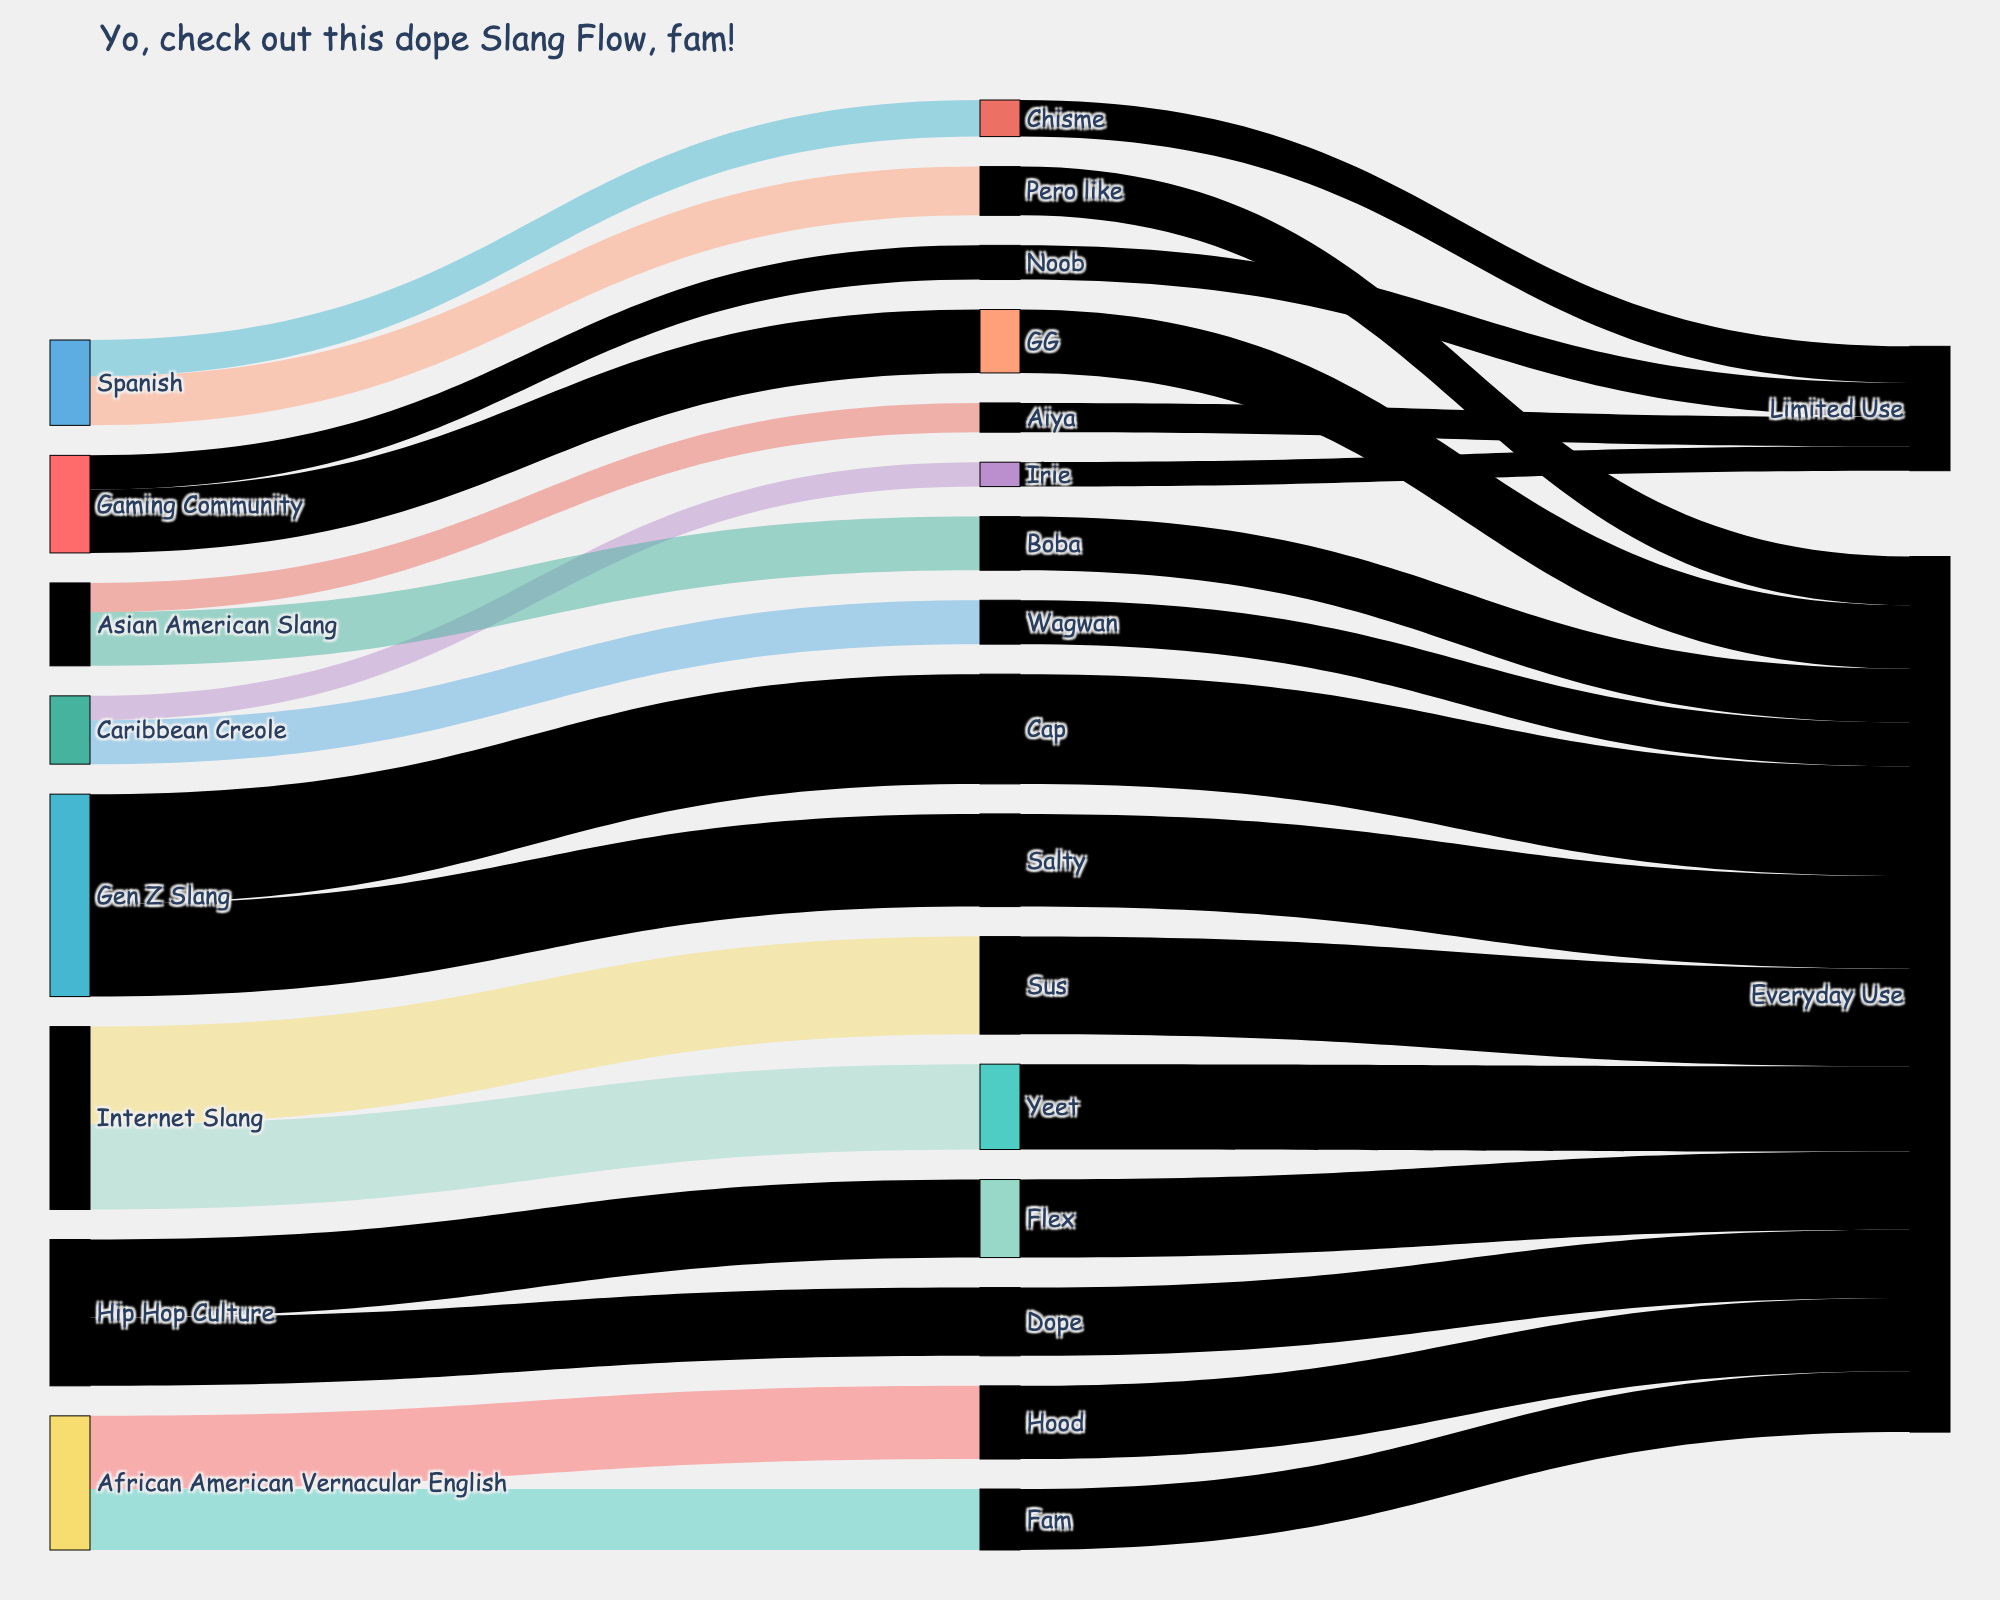Which slang term from Gen Z Slang has the highest adoption in everyday use? To find this, look at the "Gen Z Slang" category leading to "Everyday Use" and compare the values. "Cap" is 45, whereas "Salty" is 38. So, "Cap" has the highest adoption.
Answer: Cap What slang originating from Internet Slang has a higher value, "Yeet" or "Sus"? Check the values connected to "Internet Slang" in the "Everyday Use" category. "Yeet" has a value of 35 and "Sus" has a value of 40.
Answer: Sus What's the total value of slang terms that have a "Limited Use" adoption? Add the values seen in the "Limited Use" category: "Chisme" (15), "Aiya" (12), "Irie" (10), and "Noob" (14). The total is 15 + 12 + 10 + 14 = 51.
Answer: 51 Which source contributes the most slang words to "Everyday Use"? Compare the summed values leading to "Everyday Use" from each source. "Internet Slang" contributes (35+40=75), "African American Vernacular English" contributes (30+25=55), the largest is from "Gen Z Slang" (45+38=83).
Answer: Gen Z Slang Which term has the highest value across all categories? Check all values and identify the highest one. The highest value is for "Cap" which is 45.
Answer: Cap How does the contribution from "African American Vernacular English" to "Everyday Use" compare to "Gen Z Slang"? "African American Vernacular English" contributes values 30 (Hood) + 25 (Fam) = 55. "Gen Z Slang" contributes 45 (Cap) + 38 (Salty) = 83. "Gen Z Slang" contributes more.
Answer: Gen Z Slang contributes more What's the value difference between "Dope" and "Flex" from "Hip Hop Culture"? "Dope" has a value of 28 and "Flex" has a value of 32. The difference is 32 - 28 = 4.
Answer: 4 Which source has the lowest contribution to slang terms in "Everyday Use"? Compare summed values, and "Caribbean Creole" contributes only 18 (Wagwan), which is the lowest in "Everyday Use".
Answer: Caribbean Creole What’s the total value of slang terms originating from "Spanish"? Sum "Pero like" (20) and "Chisme" (15). The total is 20 + 15 = 35.
Answer: 35 